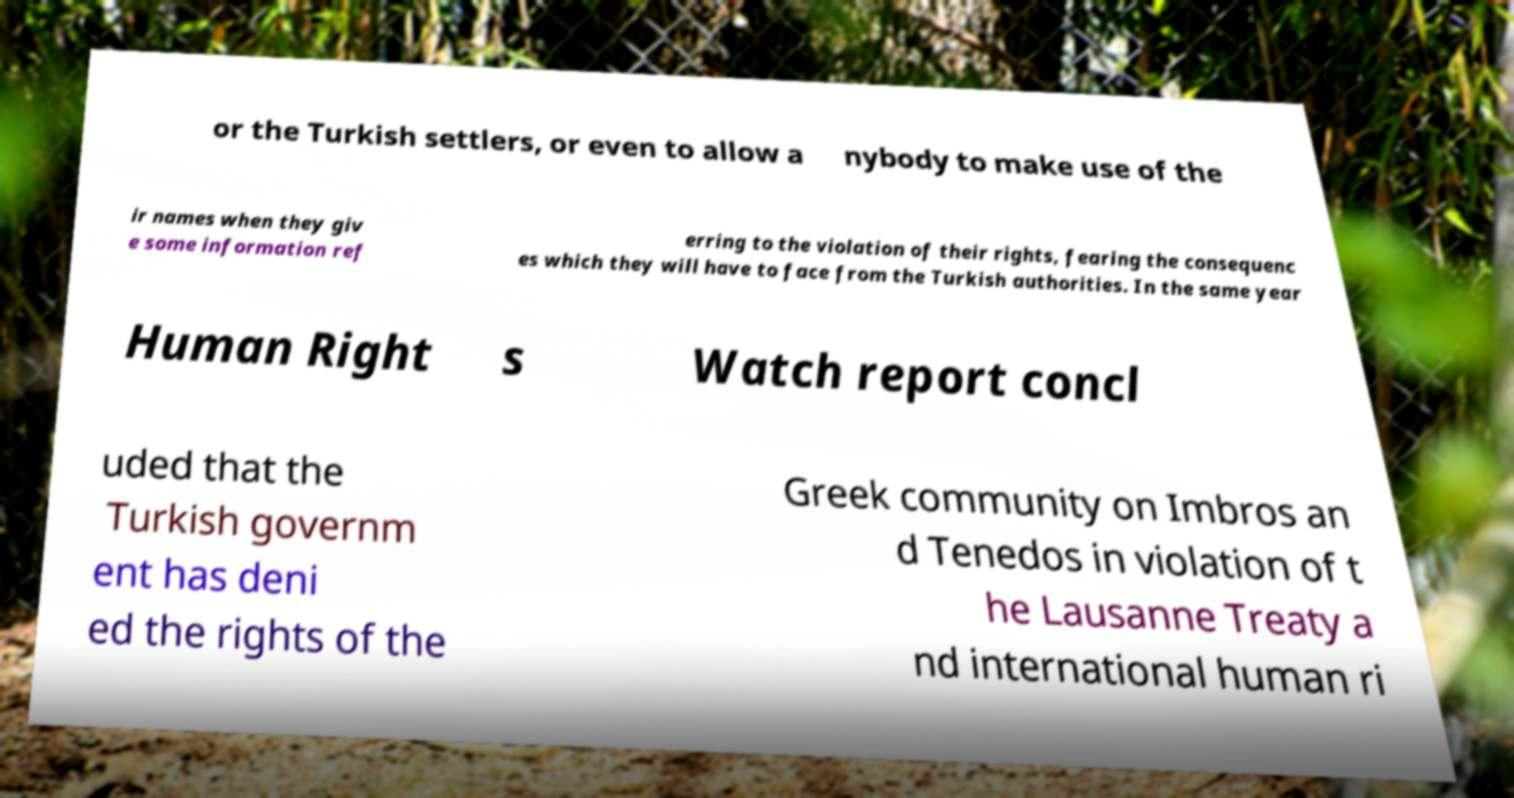Can you accurately transcribe the text from the provided image for me? or the Turkish settlers, or even to allow a nybody to make use of the ir names when they giv e some information ref erring to the violation of their rights, fearing the consequenc es which they will have to face from the Turkish authorities. In the same year Human Right s Watch report concl uded that the Turkish governm ent has deni ed the rights of the Greek community on Imbros an d Tenedos in violation of t he Lausanne Treaty a nd international human ri 